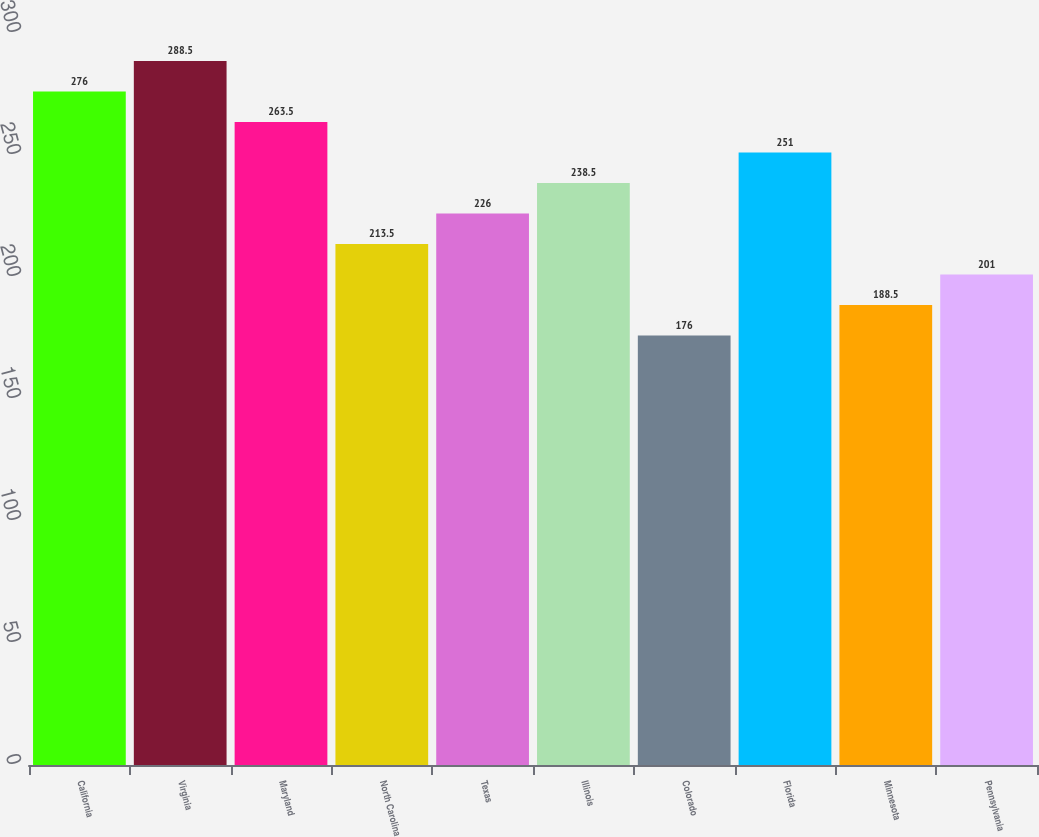Convert chart. <chart><loc_0><loc_0><loc_500><loc_500><bar_chart><fcel>California<fcel>Virginia<fcel>Maryland<fcel>North Carolina<fcel>Texas<fcel>Illinois<fcel>Colorado<fcel>Florida<fcel>Minnesota<fcel>Pennsylvania<nl><fcel>276<fcel>288.5<fcel>263.5<fcel>213.5<fcel>226<fcel>238.5<fcel>176<fcel>251<fcel>188.5<fcel>201<nl></chart> 